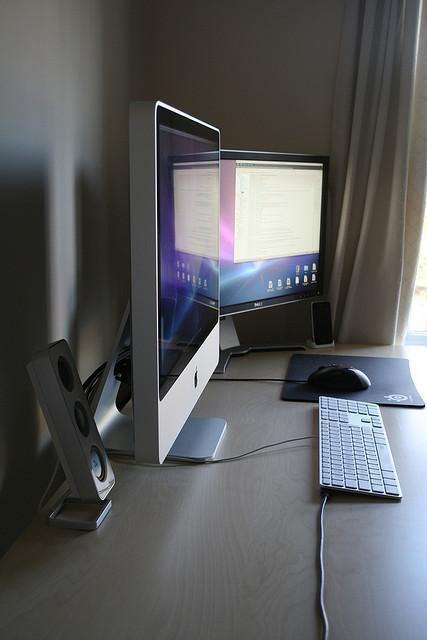How many monitors are in use?
Give a very brief answer. 2. How many computers are there?
Give a very brief answer. 2. How many tvs are there?
Give a very brief answer. 2. 